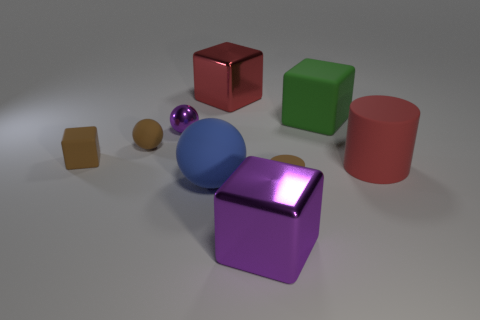Subtract all large blocks. How many blocks are left? 1 Subtract 2 blocks. How many blocks are left? 2 Subtract all red cubes. How many cubes are left? 3 Subtract all gray cubes. Subtract all brown cylinders. How many cubes are left? 4 Subtract all cylinders. How many objects are left? 7 Add 1 small yellow blocks. How many small yellow blocks exist? 1 Subtract 0 yellow cubes. How many objects are left? 9 Subtract all metal cylinders. Subtract all big red cylinders. How many objects are left? 8 Add 3 big red shiny blocks. How many big red shiny blocks are left? 4 